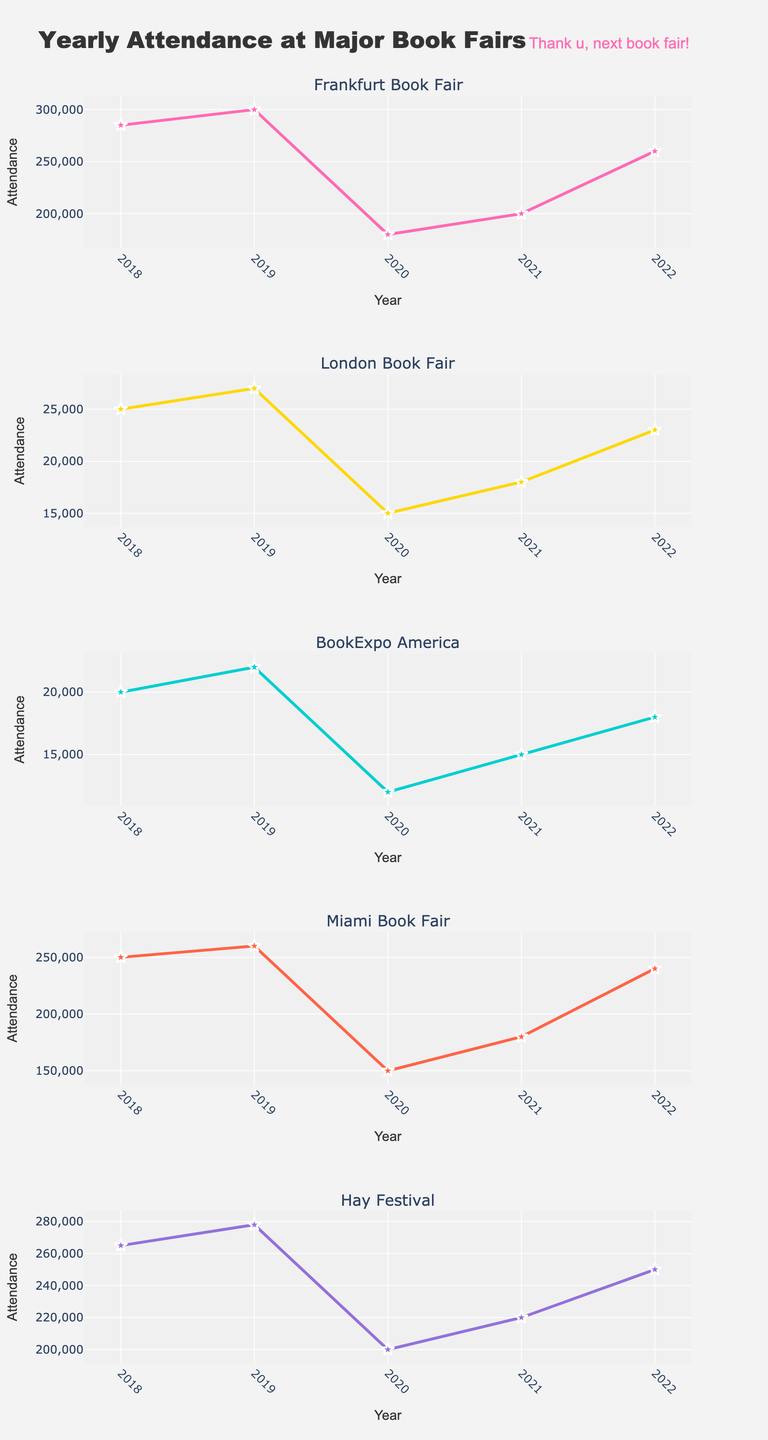What's the title of the figure? The title is displayed at the top of the figure. It reads: "Yearly Attendance at Major Book Fairs".
Answer: Yearly Attendance at Major Book Fairs How many subplots are there in the figure? The figure contains five subplots, one for each book fair or literary event mentioned in the data: Frankfurt Book Fair, London Book Fair, BookExpo America, Miami Book Fair, and Hay Festival.
Answer: Five Which book fair had the highest attendance in 2022? By looking at the 2022 data points in the subplot for each book fair, it's evident that Frankfurt Book Fair had 260,000 attendees, which is the highest compared to the others.
Answer: Frankfurt Book Fair What was the attendance of the London Book Fair in 2020 and how did it change by 2022? The attendance for the London Book Fair in 2020 was 15,000. It increased to 23,000 by 2022. The change is: 23,000 - 15,000 = 8,000.
Answer: 8,000 What is the general trend in attendance for the Miami Book Fair from 2018 to 2022? The subplot for the Miami Book Fair shows the following trend: 2018: 250,000 -> 2019: 260,000 -> 2020: 150,000 -> 2021: 180,000 -> 2022: 240,000. This indicates an initial increase, a significant drop in 2020, followed by a steady recovery.
Answer: Initial increase, significant drop in 2020, steady recovery Compare the attendance trends of the Frankfurt Book Fair and Hay Festival. Who recovered better post-2020? Both fairs had a significant drop in 2020. Frankfurt Book Fair went from 300,000 (2019) to 180,000 (2020) and recovered to 260,000 by 2022. Hay Festival dropped from 278,000 (2019) to 200,000 (2020) and recovered to 250,000 by 2022. Both fairs reached similar attendance (260,000 vs 250,000) but Frankfurt Book Fair had a higher peak recovery.
Answer: Frankfurt Book Fair Which book fair had the lowest attendance in 2019, and what was its value? Referring to the 2019 data points, BookExpo America had the lowest attendance at 22,000.
Answer: BookExpo America, 22,000 Calculate the average attendance of the Miami Book Fair over the years provided. The attendance figures for Miami Book Fair over the years are: 250,000 (2018), 260,000 (2019), 150,000 (2020), 180,000 (2021), 240,000 (2022). The average is: (250,000 + 260,000 + 150,000 + 180,000 + 240,000) / 5 = 1,080,000 / 5 = 216,000.
Answer: 216,000 What annotation is uniquely themed within the figure and where is it placed? There is an Ariana Grande-themed annotation saying "Thank u, next book fair!" placed just above the top right corner of the entire figure.
Answer: "Thank u, next book fair!" What is the color used for the attendance trend line for the BookExpo America subplot? The attendance trend line for BookExpo America is depicted in a turquoise color.
Answer: Turquoise 